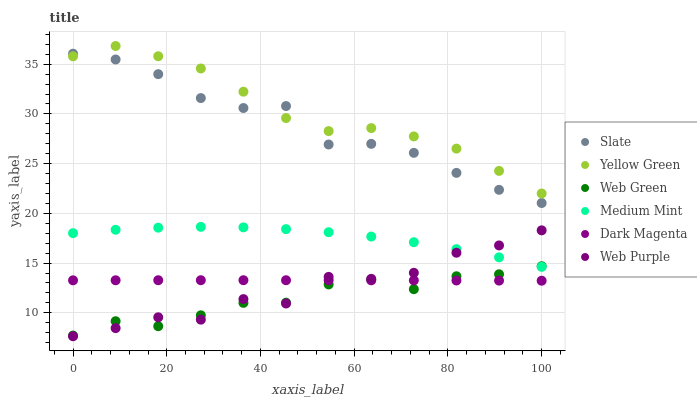Does Web Green have the minimum area under the curve?
Answer yes or no. Yes. Does Yellow Green have the maximum area under the curve?
Answer yes or no. Yes. Does Slate have the minimum area under the curve?
Answer yes or no. No. Does Slate have the maximum area under the curve?
Answer yes or no. No. Is Dark Magenta the smoothest?
Answer yes or no. Yes. Is Web Purple the roughest?
Answer yes or no. Yes. Is Yellow Green the smoothest?
Answer yes or no. No. Is Yellow Green the roughest?
Answer yes or no. No. Does Web Purple have the lowest value?
Answer yes or no. Yes. Does Slate have the lowest value?
Answer yes or no. No. Does Yellow Green have the highest value?
Answer yes or no. Yes. Does Slate have the highest value?
Answer yes or no. No. Is Web Green less than Slate?
Answer yes or no. Yes. Is Slate greater than Medium Mint?
Answer yes or no. Yes. Does Dark Magenta intersect Web Purple?
Answer yes or no. Yes. Is Dark Magenta less than Web Purple?
Answer yes or no. No. Is Dark Magenta greater than Web Purple?
Answer yes or no. No. Does Web Green intersect Slate?
Answer yes or no. No. 